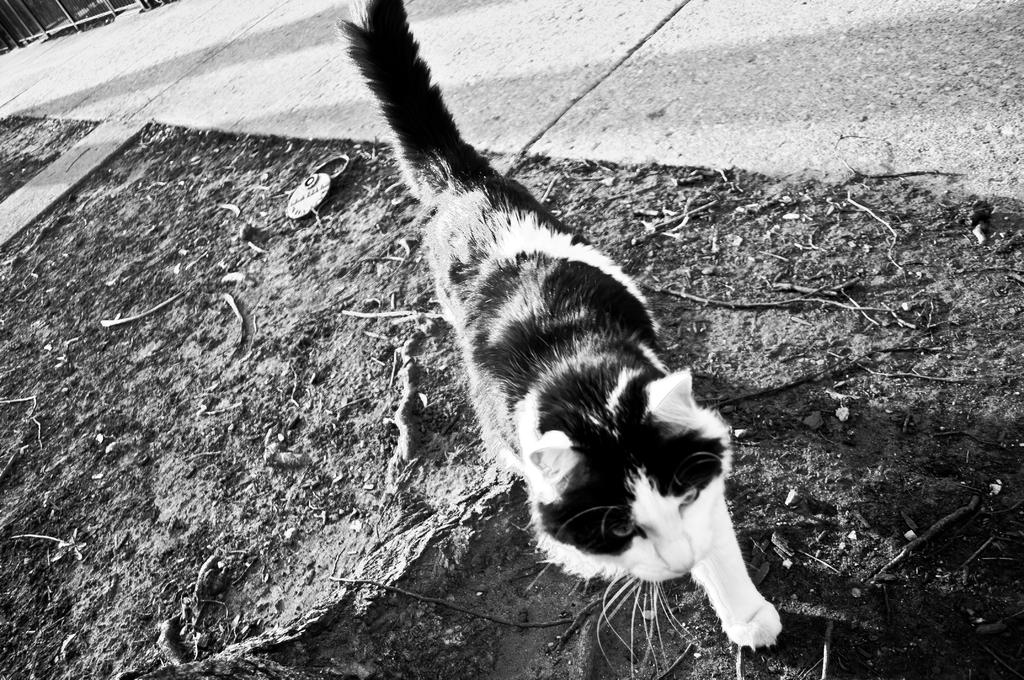What animal can be seen in the image? There is a cat in the image. What is the cat doing in the image? The cat is walking on the side of the footpath. What is the color scheme of the image? The image is black and white. How many dimes are scattered on the footpath in the image? There are no dimes present in the image; it only features a cat walking on the side of the footpath. 